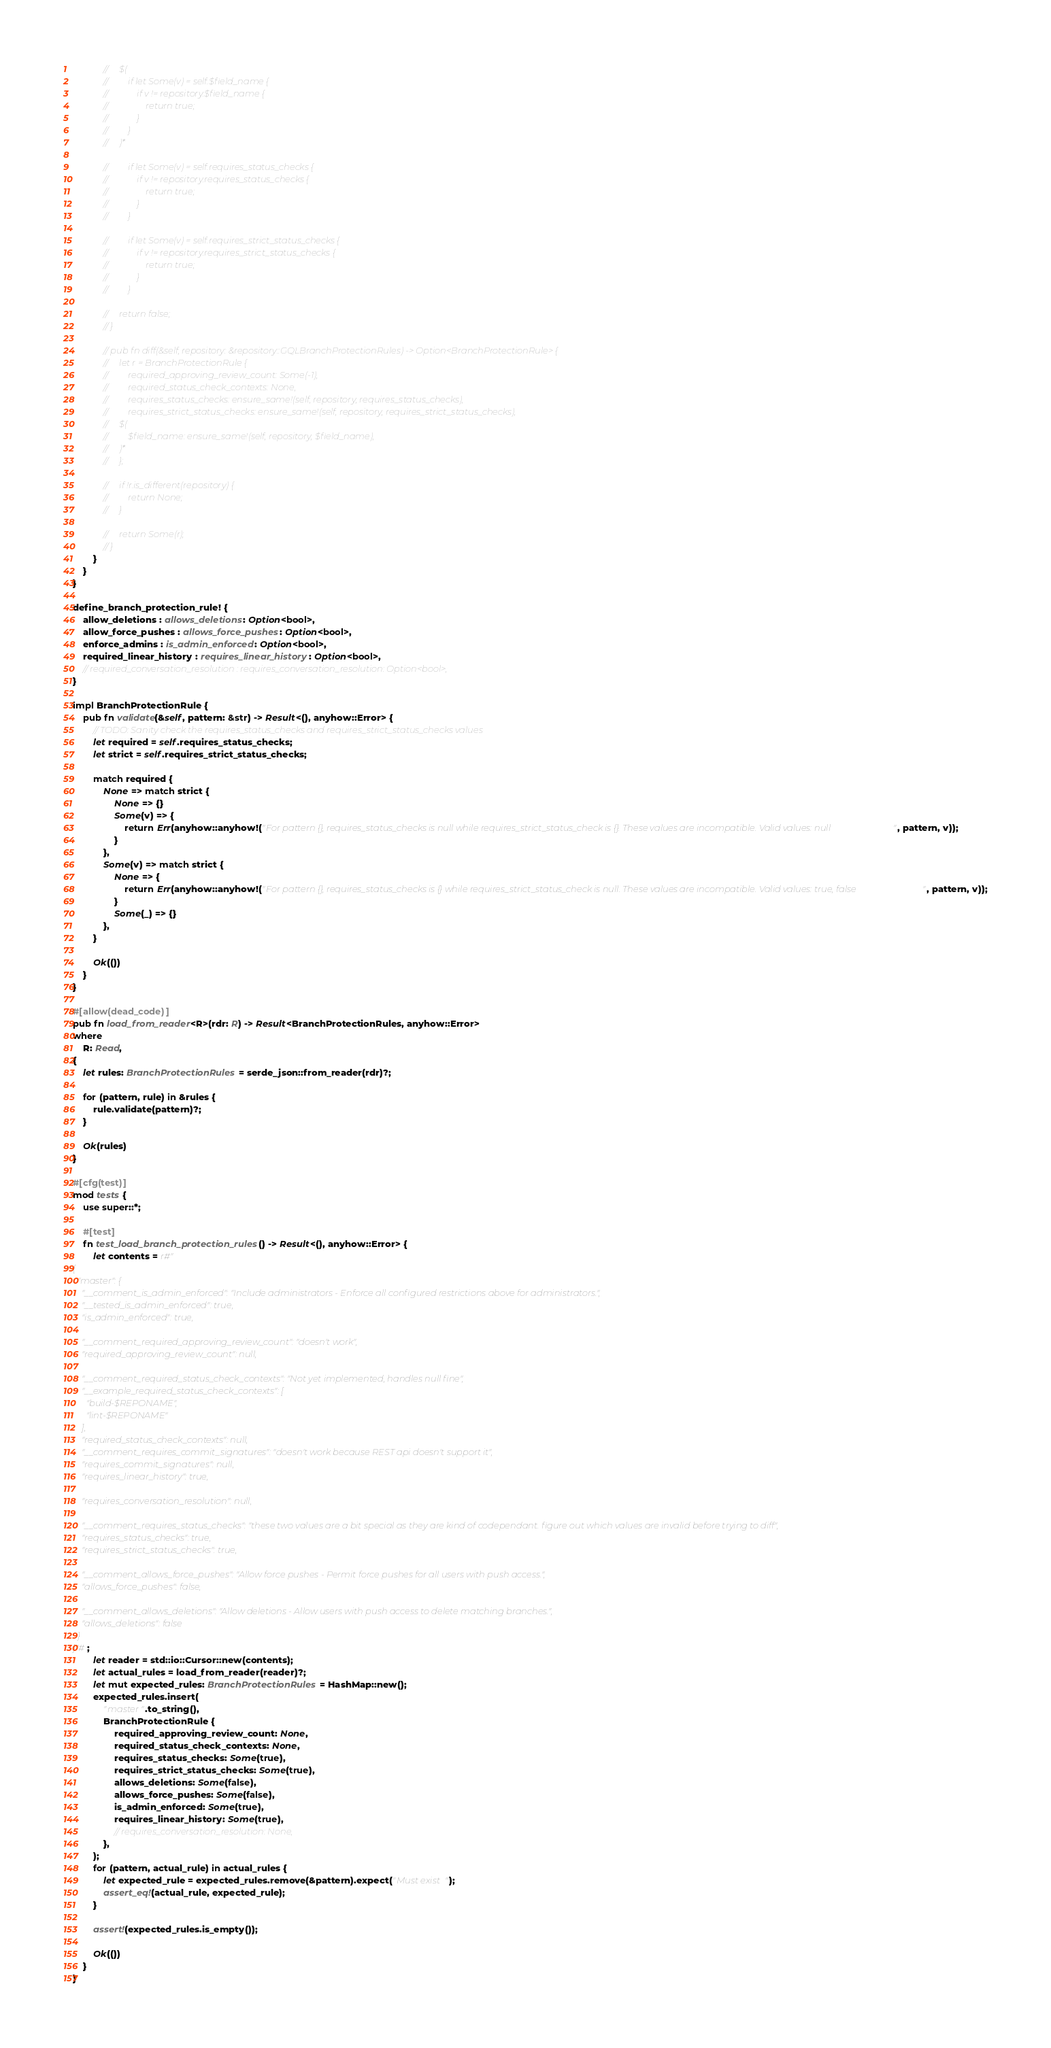<code> <loc_0><loc_0><loc_500><loc_500><_Rust_>            //     $(
            //         if let Some(v) = self.$field_name {
            //             if v != repository.$field_name {
            //                 return true;
            //             }
            //         }
            //     )*

            //         if let Some(v) = self.requires_status_checks {
            //             if v != repository.requires_status_checks {
            //                 return true;
            //             }
            //         }

            //         if let Some(v) = self.requires_strict_status_checks {
            //             if v != repository.requires_strict_status_checks {
            //                 return true;
            //             }
            //         }

            //     return false;
            // }

            // pub fn diff(&self, repository: &repository::GQLBranchProtectionRules) -> Option<BranchProtectionRule> {
            //     let r = BranchProtectionRule {
            //         required_approving_review_count: Some(-1),
            //         required_status_check_contexts: None,
            //         requires_status_checks: ensure_same!(self, repository, requires_status_checks),
            //         requires_strict_status_checks: ensure_same!(self, repository, requires_strict_status_checks),
            //     $(
            //         $field_name: ensure_same!(self, repository, $field_name),
            //     )*
            //     };

            //     if !r.is_different(repository) {
            //         return None;
            //     }

            //     return Some(r);
            // }
        }
    }
}

define_branch_protection_rule! {
    allow_deletions : allows_deletions: Option<bool>,
    allow_force_pushes : allows_force_pushes: Option<bool>,
    enforce_admins : is_admin_enforced: Option<bool>,
    required_linear_history : requires_linear_history: Option<bool>,
    // required_conversation_resolution : requires_conversation_resolution: Option<bool>,
}

impl BranchProtectionRule {
    pub fn validate(&self, pattern: &str) -> Result<(), anyhow::Error> {
        // TODO: Sanity check the requires_status_checks and requires_strict_status_checks values
        let required = self.requires_status_checks;
        let strict = self.requires_strict_status_checks;

        match required {
            None => match strict {
                None => {}
                Some(v) => {
                    return Err(anyhow::anyhow!("For pattern {}, requires_status_checks is null while requires_strict_status_check is {}. These values are incompatible. Valid values: null", pattern, v));
                }
            },
            Some(v) => match strict {
                None => {
                    return Err(anyhow::anyhow!("For pattern {}, requires_status_checks is {} while requires_strict_status_check is null. These values are incompatible. Valid values: true, false", pattern, v));
                }
                Some(_) => {}
            },
        }

        Ok(())
    }
}

#[allow(dead_code)]
pub fn load_from_reader<R>(rdr: R) -> Result<BranchProtectionRules, anyhow::Error>
where
    R: Read,
{
    let rules: BranchProtectionRules = serde_json::from_reader(rdr)?;

    for (pattern, rule) in &rules {
        rule.validate(pattern)?;
    }

    Ok(rules)
}

#[cfg(test)]
mod tests {
    use super::*;

    #[test]
    fn test_load_branch_protection_rules() -> Result<(), anyhow::Error> {
        let contents = r#"
{
  "master": {
    "__comment_is_admin_enforced": "Include administrators - Enforce all configured restrictions above for administrators.",
    "__tested_is_admin_enforced": true,
    "is_admin_enforced": true,

    "__comment_required_approving_review_count": "doesn't work",
    "required_approving_review_count": null,

    "__comment_required_status_check_contexts": "Not yet implemented, handles null fine",
    "__example_required_status_check_contexts": [
      "build-$REPONAME",
      "lint-$REPONAME"
    ],
    "required_status_check_contexts": null,
    "__comment_requires_commit_signatures": "doesn't work because REST api doesn't support it",
    "requires_commit_signatures": null,
    "requires_linear_history": true,

    "requires_conversation_resolution": null,

    "__comment_requires_status_checks": "these two values are a bit special as they are kind of codependant. figure out which values are invalid before trying to diff",
    "requires_status_checks": true,
    "requires_strict_status_checks": true,

    "__comment_allows_force_pushes": "Allow force pushes - Permit force pushes for all users with push access.",
    "allows_force_pushes": false,

    "__comment_allows_deletions": "Allow deletions - Allow users with push access to delete matching branches.",
    "allows_deletions": false
  }
}"#;
        let reader = std::io::Cursor::new(contents);
        let actual_rules = load_from_reader(reader)?;
        let mut expected_rules: BranchProtectionRules = HashMap::new();
        expected_rules.insert(
            "master".to_string(),
            BranchProtectionRule {
                required_approving_review_count: None,
                required_status_check_contexts: None,
                requires_status_checks: Some(true),
                requires_strict_status_checks: Some(true),
                allows_deletions: Some(false),
                allows_force_pushes: Some(false),
                is_admin_enforced: Some(true),
                requires_linear_history: Some(true),
                // requires_conversation_resolution: None,
            },
        );
        for (pattern, actual_rule) in actual_rules {
            let expected_rule = expected_rules.remove(&pattern).expect("Must exist");
            assert_eq!(actual_rule, expected_rule);
        }

        assert!(expected_rules.is_empty());

        Ok(())
    }
}
</code> 